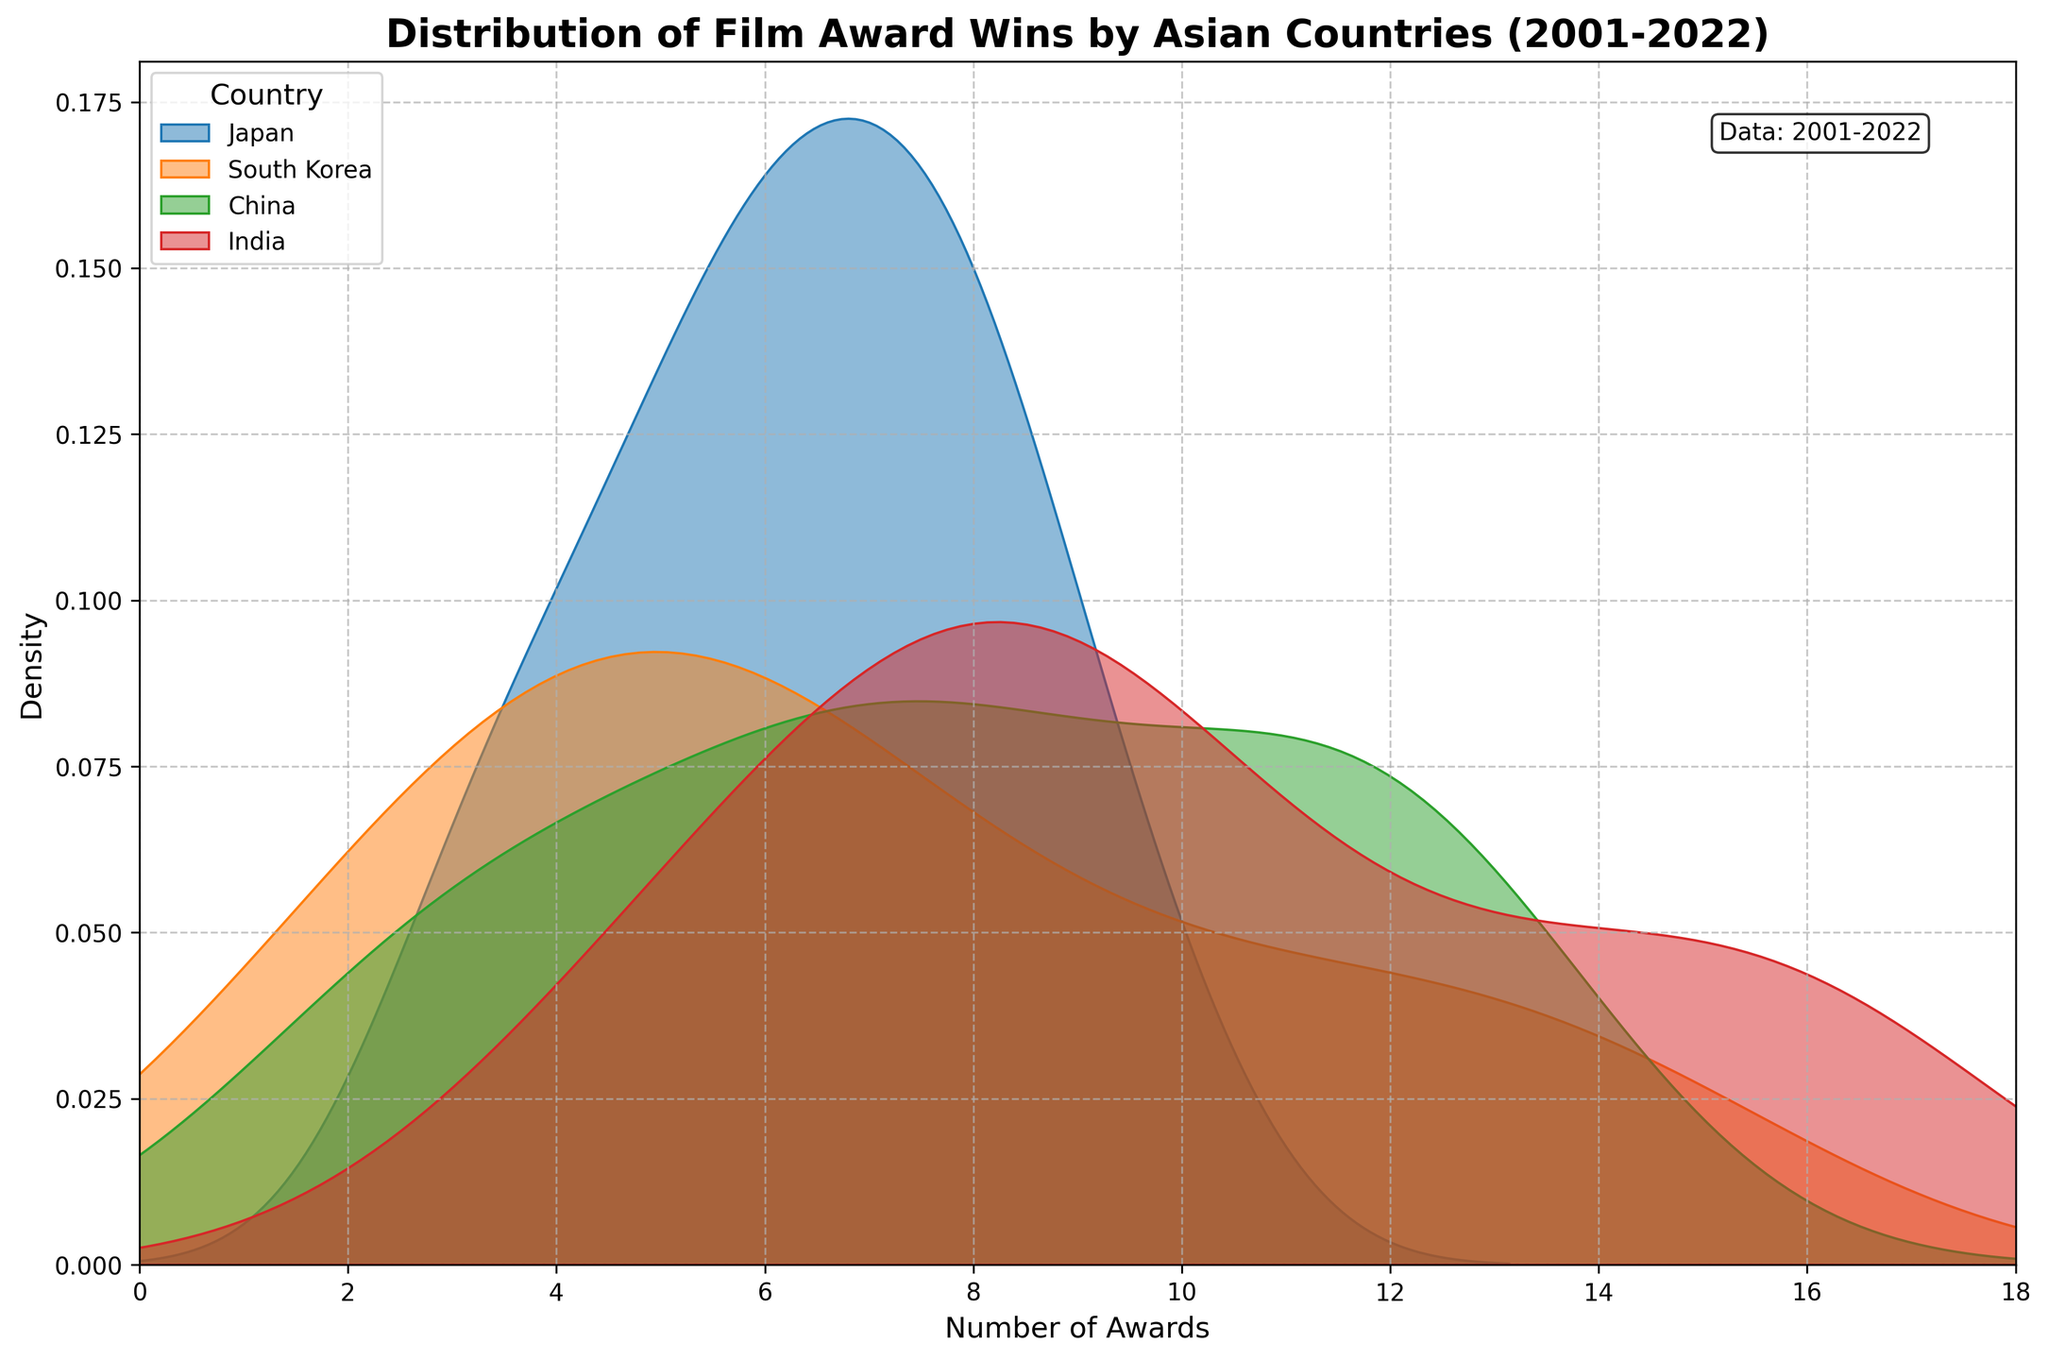Which country appears to have the densest distribution of film award wins around the higher end of the awards scale? The densest distribution around the higher end of the awards scale can be inferred by looking at the peak densities that extend the furthest to the right. South Korea's and China's density plots peak and extend further to the higher number of awards.
Answer: South Korea and China What is the title of the figure? The title can be found at the top of the figure. It reads "Distribution of Film Award Wins by Asian Countries (2001-2022)".
Answer: Distribution of Film Award Wins by Asian Countries (2001-2022) How many countries are represented in the figure? The number of countries can be deduced by counting the distinct labels in the legend. The legend shows four countries.
Answer: Four Which country has the most rightward peak in its density plot? The most rightward peak can be identified by examining which country's plot extends furthest to the right. South Korea's plot appears to peak furthest to the right.
Answer: South Korea What is the median number of awards for Japan based on its density plot? To determine the median number of awards for Japan, look at where the vertical line would split Japan’s plot into two equal halves horizontally. Japan's peak density is near 7, indicating a median close to that number.
Answer: Approximately 7 Comparing Japan and India, which country shows a greater density of lower awards around 5? To find out which country shows a higher density around the lower award numbers (like 5), compare the height of their density plots at that value. Japan shows a notably higher density around 5 compared to India.
Answer: Japan Which colors are used in the figure to differentiate between the countries? The colors used to represent the countries can be identified directly from the figure. The legend indicates the specific colors used.
Answer: Red, Blue, Green, Orange Comparing the distributions, which country’s awards increased the most gradually over the years? Look for the density plot with the least skew or one that most gradually shifts to the right. Japan's distribution appears more smoothly spread out, indicating a gradual increase.
Answer: Japan 